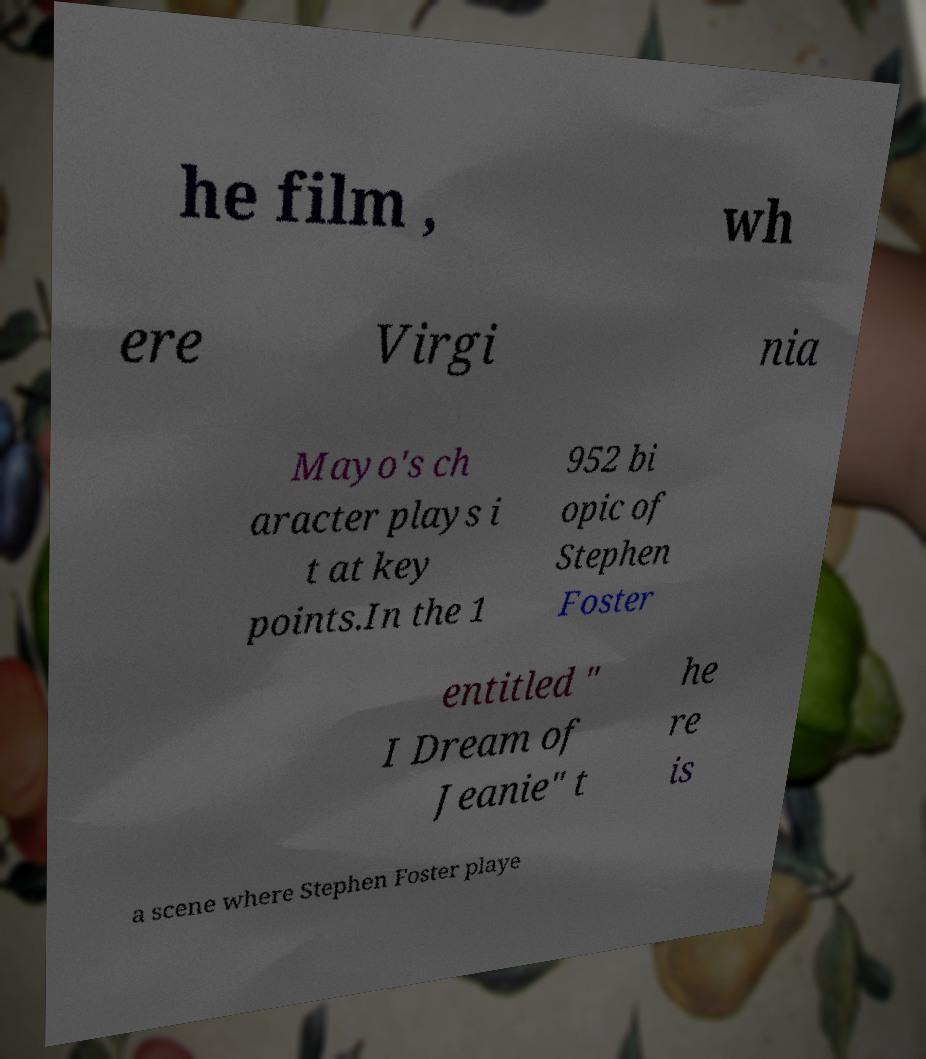Could you assist in decoding the text presented in this image and type it out clearly? he film , wh ere Virgi nia Mayo's ch aracter plays i t at key points.In the 1 952 bi opic of Stephen Foster entitled " I Dream of Jeanie" t he re is a scene where Stephen Foster playe 